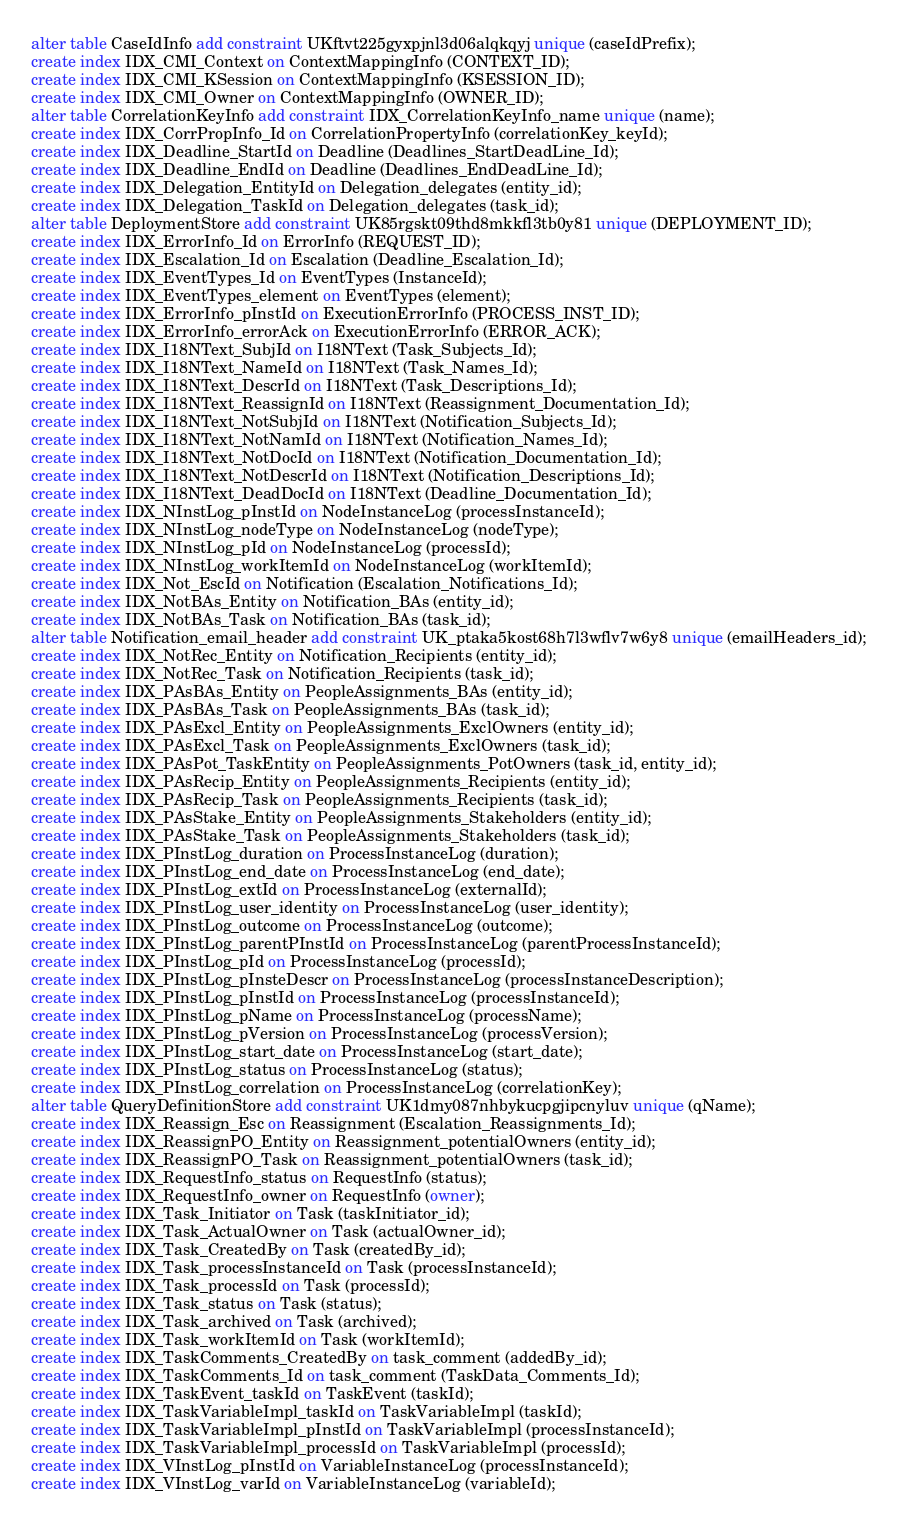<code> <loc_0><loc_0><loc_500><loc_500><_SQL_>alter table CaseIdInfo add constraint UKftvt225gyxpjnl3d06alqkqyj unique (caseIdPrefix);
create index IDX_CMI_Context on ContextMappingInfo (CONTEXT_ID);
create index IDX_CMI_KSession on ContextMappingInfo (KSESSION_ID);
create index IDX_CMI_Owner on ContextMappingInfo (OWNER_ID);
alter table CorrelationKeyInfo add constraint IDX_CorrelationKeyInfo_name unique (name);
create index IDX_CorrPropInfo_Id on CorrelationPropertyInfo (correlationKey_keyId);
create index IDX_Deadline_StartId on Deadline (Deadlines_StartDeadLine_Id);
create index IDX_Deadline_EndId on Deadline (Deadlines_EndDeadLine_Id);
create index IDX_Delegation_EntityId on Delegation_delegates (entity_id);
create index IDX_Delegation_TaskId on Delegation_delegates (task_id);
alter table DeploymentStore add constraint UK85rgskt09thd8mkkfl3tb0y81 unique (DEPLOYMENT_ID);
create index IDX_ErrorInfo_Id on ErrorInfo (REQUEST_ID);
create index IDX_Escalation_Id on Escalation (Deadline_Escalation_Id);
create index IDX_EventTypes_Id on EventTypes (InstanceId);
create index IDX_EventTypes_element on EventTypes (element);
create index IDX_ErrorInfo_pInstId on ExecutionErrorInfo (PROCESS_INST_ID);
create index IDX_ErrorInfo_errorAck on ExecutionErrorInfo (ERROR_ACK);
create index IDX_I18NText_SubjId on I18NText (Task_Subjects_Id);
create index IDX_I18NText_NameId on I18NText (Task_Names_Id);
create index IDX_I18NText_DescrId on I18NText (Task_Descriptions_Id);
create index IDX_I18NText_ReassignId on I18NText (Reassignment_Documentation_Id);
create index IDX_I18NText_NotSubjId on I18NText (Notification_Subjects_Id);
create index IDX_I18NText_NotNamId on I18NText (Notification_Names_Id);
create index IDX_I18NText_NotDocId on I18NText (Notification_Documentation_Id);
create index IDX_I18NText_NotDescrId on I18NText (Notification_Descriptions_Id);
create index IDX_I18NText_DeadDocId on I18NText (Deadline_Documentation_Id);
create index IDX_NInstLog_pInstId on NodeInstanceLog (processInstanceId);
create index IDX_NInstLog_nodeType on NodeInstanceLog (nodeType);
create index IDX_NInstLog_pId on NodeInstanceLog (processId);
create index IDX_NInstLog_workItemId on NodeInstanceLog (workItemId);
create index IDX_Not_EscId on Notification (Escalation_Notifications_Id);
create index IDX_NotBAs_Entity on Notification_BAs (entity_id);
create index IDX_NotBAs_Task on Notification_BAs (task_id);
alter table Notification_email_header add constraint UK_ptaka5kost68h7l3wflv7w6y8 unique (emailHeaders_id);
create index IDX_NotRec_Entity on Notification_Recipients (entity_id);
create index IDX_NotRec_Task on Notification_Recipients (task_id);
create index IDX_PAsBAs_Entity on PeopleAssignments_BAs (entity_id);
create index IDX_PAsBAs_Task on PeopleAssignments_BAs (task_id);
create index IDX_PAsExcl_Entity on PeopleAssignments_ExclOwners (entity_id);
create index IDX_PAsExcl_Task on PeopleAssignments_ExclOwners (task_id);
create index IDX_PAsPot_TaskEntity on PeopleAssignments_PotOwners (task_id, entity_id);
create index IDX_PAsRecip_Entity on PeopleAssignments_Recipients (entity_id);
create index IDX_PAsRecip_Task on PeopleAssignments_Recipients (task_id);
create index IDX_PAsStake_Entity on PeopleAssignments_Stakeholders (entity_id);
create index IDX_PAsStake_Task on PeopleAssignments_Stakeholders (task_id);
create index IDX_PInstLog_duration on ProcessInstanceLog (duration);
create index IDX_PInstLog_end_date on ProcessInstanceLog (end_date);
create index IDX_PInstLog_extId on ProcessInstanceLog (externalId);
create index IDX_PInstLog_user_identity on ProcessInstanceLog (user_identity);
create index IDX_PInstLog_outcome on ProcessInstanceLog (outcome);
create index IDX_PInstLog_parentPInstId on ProcessInstanceLog (parentProcessInstanceId);
create index IDX_PInstLog_pId on ProcessInstanceLog (processId);
create index IDX_PInstLog_pInsteDescr on ProcessInstanceLog (processInstanceDescription);
create index IDX_PInstLog_pInstId on ProcessInstanceLog (processInstanceId);
create index IDX_PInstLog_pName on ProcessInstanceLog (processName);
create index IDX_PInstLog_pVersion on ProcessInstanceLog (processVersion);
create index IDX_PInstLog_start_date on ProcessInstanceLog (start_date);
create index IDX_PInstLog_status on ProcessInstanceLog (status);
create index IDX_PInstLog_correlation on ProcessInstanceLog (correlationKey);
alter table QueryDefinitionStore add constraint UK1dmy087nhbykucpgjipcnyluv unique (qName);
create index IDX_Reassign_Esc on Reassignment (Escalation_Reassignments_Id);
create index IDX_ReassignPO_Entity on Reassignment_potentialOwners (entity_id);
create index IDX_ReassignPO_Task on Reassignment_potentialOwners (task_id);
create index IDX_RequestInfo_status on RequestInfo (status);
create index IDX_RequestInfo_owner on RequestInfo (owner);
create index IDX_Task_Initiator on Task (taskInitiator_id);
create index IDX_Task_ActualOwner on Task (actualOwner_id);
create index IDX_Task_CreatedBy on Task (createdBy_id);
create index IDX_Task_processInstanceId on Task (processInstanceId);
create index IDX_Task_processId on Task (processId);
create index IDX_Task_status on Task (status);
create index IDX_Task_archived on Task (archived);
create index IDX_Task_workItemId on Task (workItemId);
create index IDX_TaskComments_CreatedBy on task_comment (addedBy_id);
create index IDX_TaskComments_Id on task_comment (TaskData_Comments_Id);
create index IDX_TaskEvent_taskId on TaskEvent (taskId);
create index IDX_TaskVariableImpl_taskId on TaskVariableImpl (taskId);
create index IDX_TaskVariableImpl_pInstId on TaskVariableImpl (processInstanceId);
create index IDX_TaskVariableImpl_processId on TaskVariableImpl (processId);
create index IDX_VInstLog_pInstId on VariableInstanceLog (processInstanceId);
create index IDX_VInstLog_varId on VariableInstanceLog (variableId);</code> 